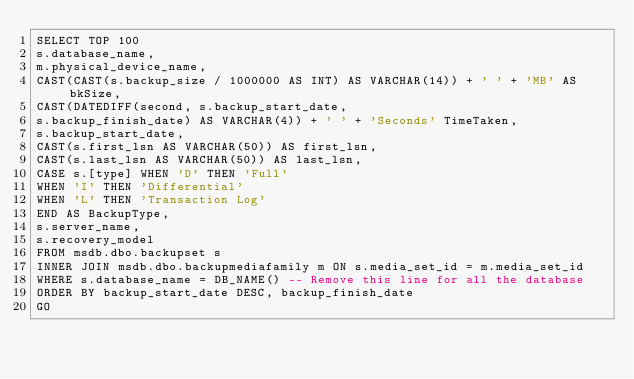<code> <loc_0><loc_0><loc_500><loc_500><_SQL_>SELECT TOP 100
s.database_name,
m.physical_device_name,
CAST(CAST(s.backup_size / 1000000 AS INT) AS VARCHAR(14)) + ' ' + 'MB' AS bkSize,
CAST(DATEDIFF(second, s.backup_start_date,
s.backup_finish_date) AS VARCHAR(4)) + ' ' + 'Seconds' TimeTaken,
s.backup_start_date,
CAST(s.first_lsn AS VARCHAR(50)) AS first_lsn,
CAST(s.last_lsn AS VARCHAR(50)) AS last_lsn,
CASE s.[type] WHEN 'D' THEN 'Full'
WHEN 'I' THEN 'Differential'
WHEN 'L' THEN 'Transaction Log'
END AS BackupType,
s.server_name,
s.recovery_model
FROM msdb.dbo.backupset s
INNER JOIN msdb.dbo.backupmediafamily m ON s.media_set_id = m.media_set_id
WHERE s.database_name = DB_NAME() -- Remove this line for all the database
ORDER BY backup_start_date DESC, backup_finish_date
GO</code> 